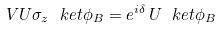<formula> <loc_0><loc_0><loc_500><loc_500>V U \sigma _ { z } \ k e t { \phi } _ { B } = e ^ { i \delta } \, U \ k e t { \phi } _ { B }</formula> 